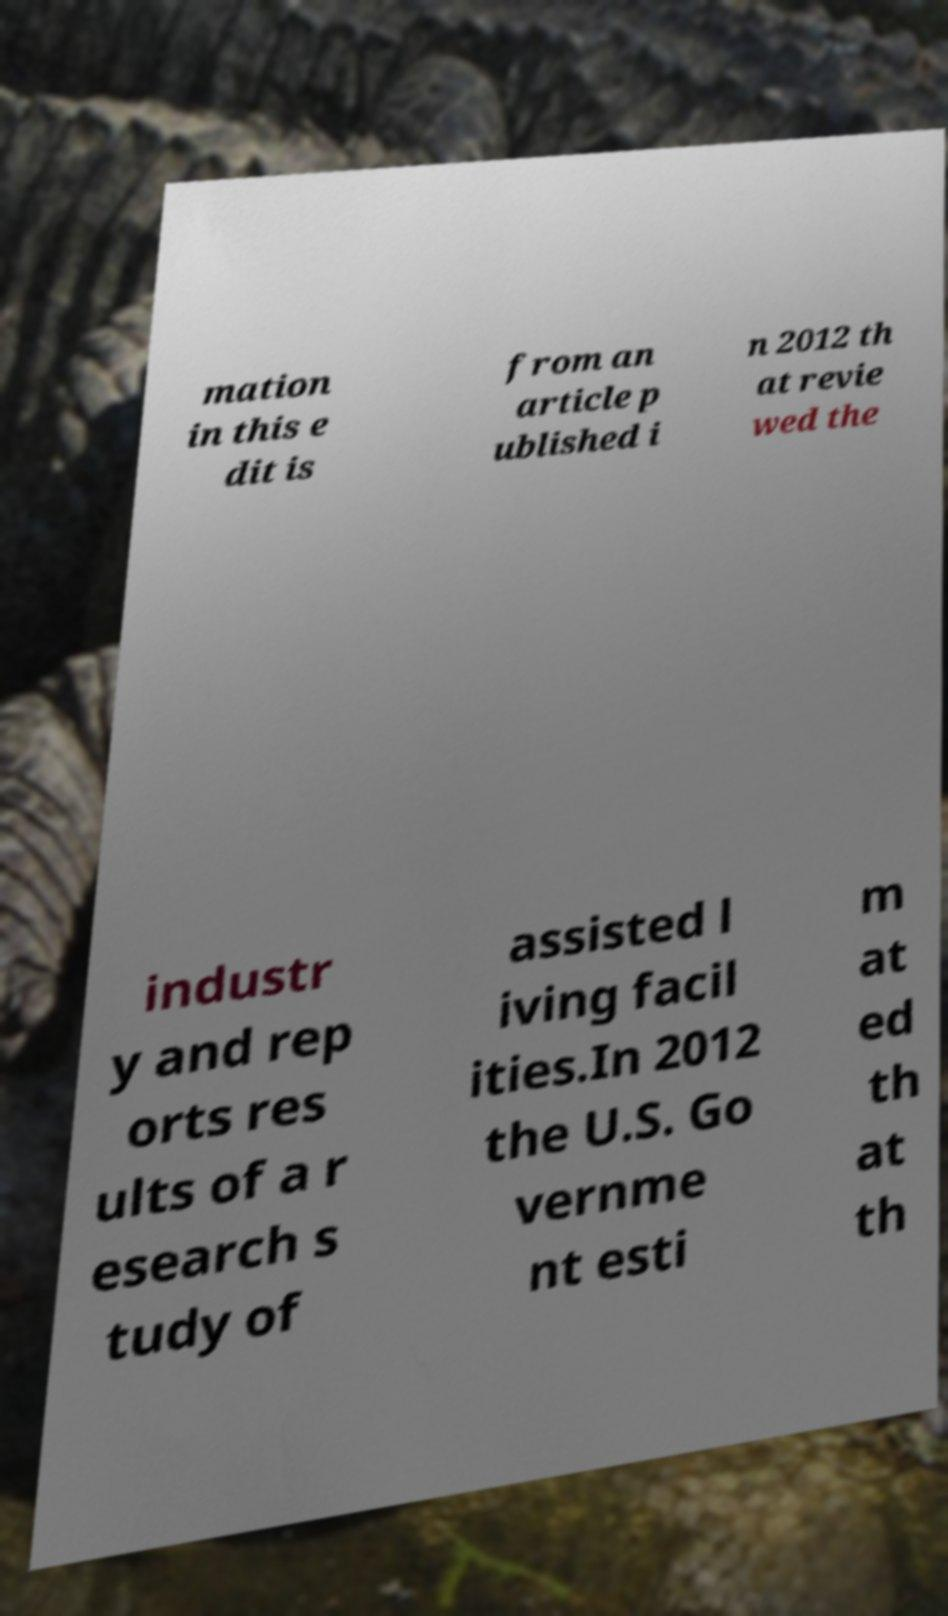Could you extract and type out the text from this image? mation in this e dit is from an article p ublished i n 2012 th at revie wed the industr y and rep orts res ults of a r esearch s tudy of assisted l iving facil ities.In 2012 the U.S. Go vernme nt esti m at ed th at th 